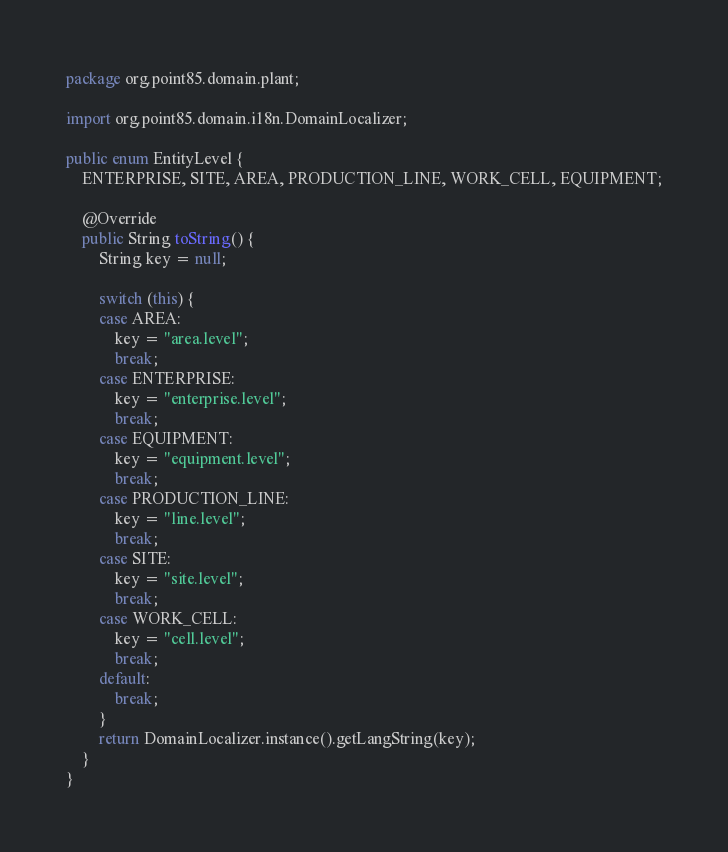Convert code to text. <code><loc_0><loc_0><loc_500><loc_500><_Java_>package org.point85.domain.plant;

import org.point85.domain.i18n.DomainLocalizer;

public enum EntityLevel {
	ENTERPRISE, SITE, AREA, PRODUCTION_LINE, WORK_CELL, EQUIPMENT;

	@Override
	public String toString() {
		String key = null;

		switch (this) {
		case AREA:
			key = "area.level";
			break;
		case ENTERPRISE:
			key = "enterprise.level";
			break;
		case EQUIPMENT:
			key = "equipment.level";
			break;
		case PRODUCTION_LINE:
			key = "line.level";
			break;
		case SITE:
			key = "site.level";
			break;
		case WORK_CELL:
			key = "cell.level";
			break;
		default:
			break;
		}
		return DomainLocalizer.instance().getLangString(key);
	}
}
</code> 